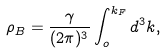Convert formula to latex. <formula><loc_0><loc_0><loc_500><loc_500>\rho _ { B } = \frac { \gamma } { ( 2 \pi ) ^ { 3 } } \int ^ { k _ { F } } _ { o } d ^ { 3 } k ,</formula> 